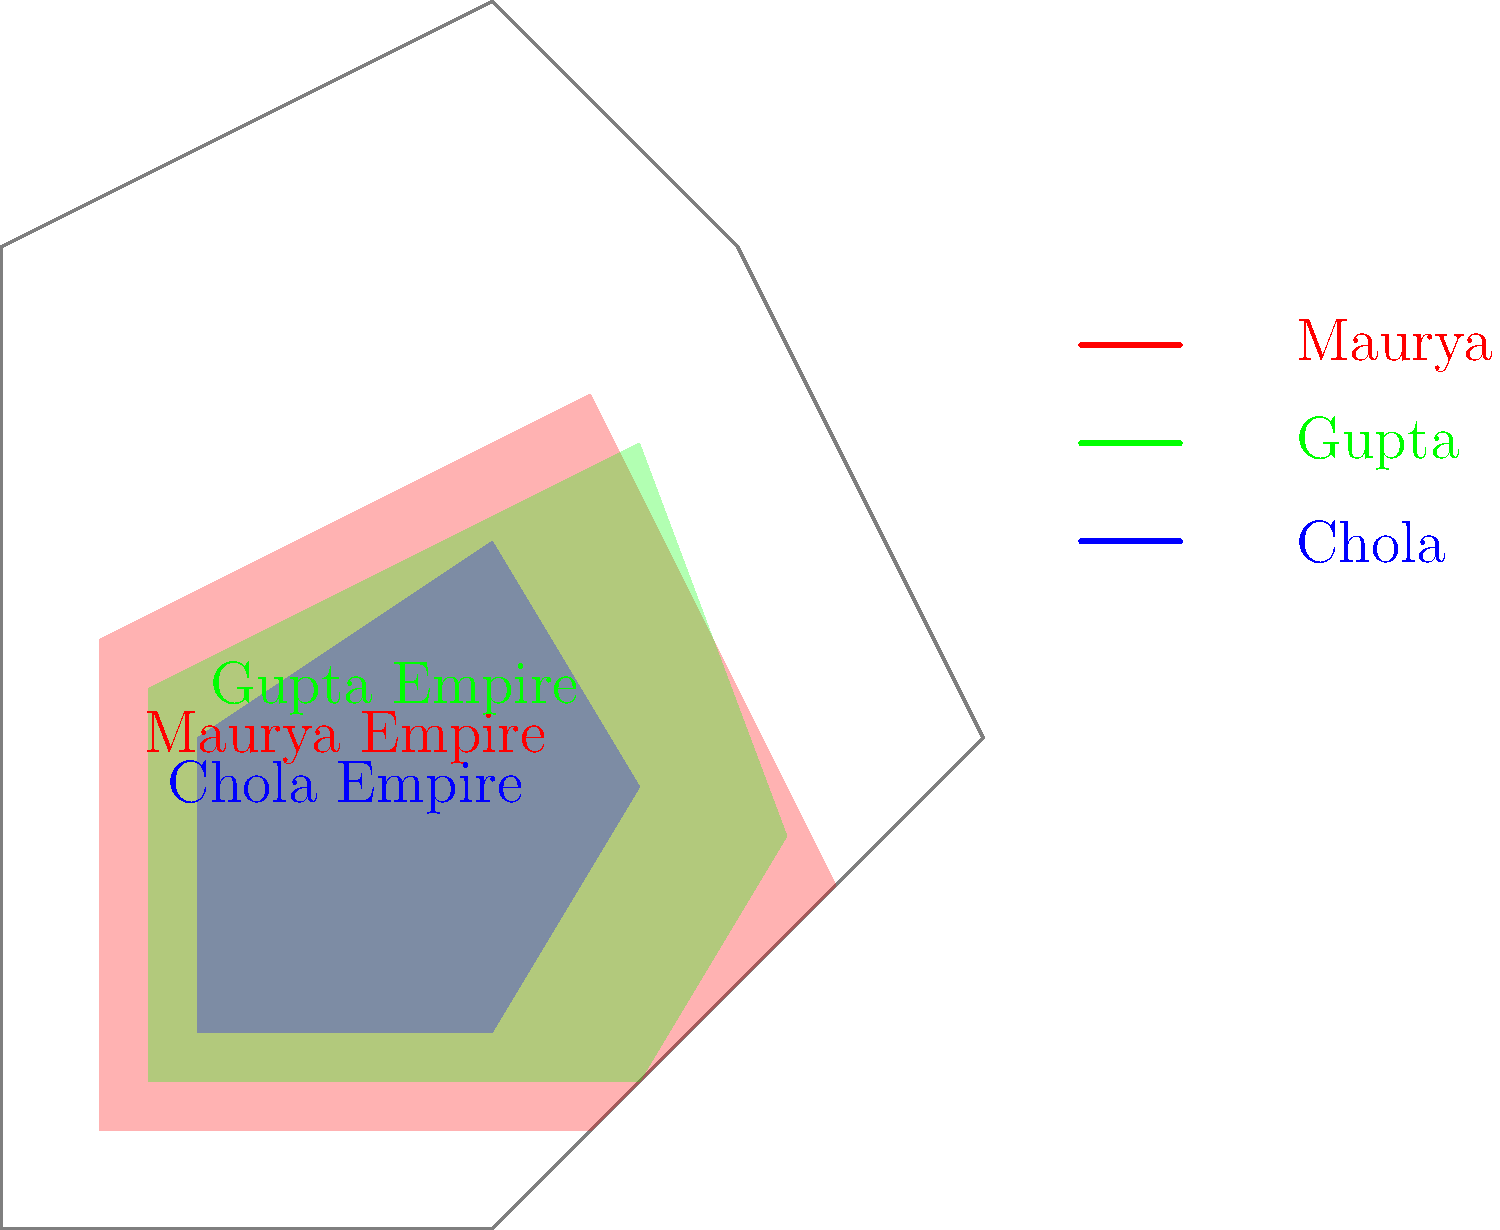Based on the map showing the territorial expansions of three major dynasties in ancient India, which empire had the largest territorial extent? To determine which empire had the largest territorial extent, we need to analyze the map carefully:

1. The Maurya Empire (red) covers the largest area on the map, extending from the northern regions to central India.
2. The Gupta Empire (green) has a significant presence but covers a slightly smaller area compared to the Maurya Empire.
3. The Chola Empire (blue) has the smallest territorial extent among the three, primarily concentrated in the southern part of India.

Step-by-step analysis:
1. The Maurya Empire's territory stretches from the northernmost point of the map to the central regions, covering a vast area.
2. The Gupta Empire's territory overlaps with much of the Maurya Empire but doesn't extend as far north or south.
3. The Chola Empire's territory is more limited, focusing on the southern part of India.

Comparing the three:
- Maurya Empire: Largest area, covering most of northern and central India.
- Gupta Empire: Second largest, with significant overlap with Maurya but slightly smaller extent.
- Chola Empire: Smallest among the three, concentrated in southern India.

Therefore, based on the visual representation, the Maurya Empire had the largest territorial extent among the three dynasties shown.
Answer: Maurya Empire 